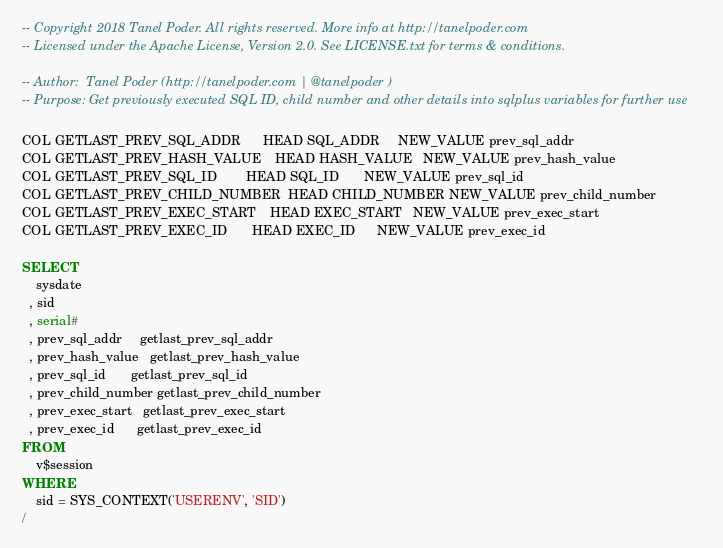<code> <loc_0><loc_0><loc_500><loc_500><_SQL_>-- Copyright 2018 Tanel Poder. All rights reserved. More info at http://tanelpoder.com
-- Licensed under the Apache License, Version 2.0. See LICENSE.txt for terms & conditions.

-- Author:  Tanel Poder (http://tanelpoder.com | @tanelpoder )
-- Purpose: Get previously executed SQL ID, child number and other details into sqlplus variables for further use

COL GETLAST_PREV_SQL_ADDR      HEAD SQL_ADDR     NEW_VALUE prev_sql_addr
COL GETLAST_PREV_HASH_VALUE    HEAD HASH_VALUE   NEW_VALUE prev_hash_value
COL GETLAST_PREV_SQL_ID        HEAD SQL_ID       NEW_VALUE prev_sql_id
COL GETLAST_PREV_CHILD_NUMBER  HEAD CHILD_NUMBER NEW_VALUE prev_child_number
COL GETLAST_PREV_EXEC_START    HEAD EXEC_START   NEW_VALUE prev_exec_start
COL GETLAST_PREV_EXEC_ID       HEAD EXEC_ID      NEW_VALUE prev_exec_id

SELECT
    sysdate
  , sid
  , serial#
  , prev_sql_addr     getlast_prev_sql_addr    
  , prev_hash_value   getlast_prev_hash_value  
  , prev_sql_id       getlast_prev_sql_id      
  , prev_child_number getlast_prev_child_number
  , prev_exec_start   getlast_prev_exec_start  
  , prev_exec_id      getlast_prev_exec_id     
FROM
    v$session
WHERE
    sid = SYS_CONTEXT('USERENV', 'SID')
/

</code> 